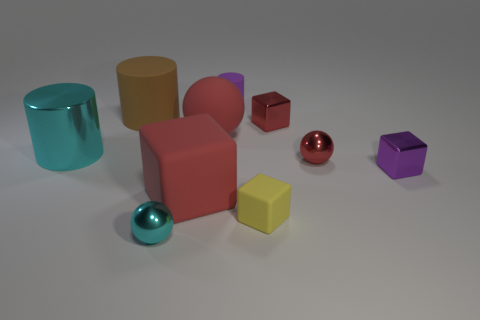Subtract all small cyan balls. How many balls are left? 2 Subtract all blocks. How many objects are left? 6 Subtract 2 balls. How many balls are left? 1 Subtract all red spheres. How many spheres are left? 1 Subtract all blue cubes. Subtract all green spheres. How many cubes are left? 4 Subtract all red balls. How many purple cylinders are left? 1 Subtract all large brown rubber objects. Subtract all large balls. How many objects are left? 8 Add 3 small spheres. How many small spheres are left? 5 Add 7 large green things. How many large green things exist? 7 Subtract 0 gray cylinders. How many objects are left? 10 